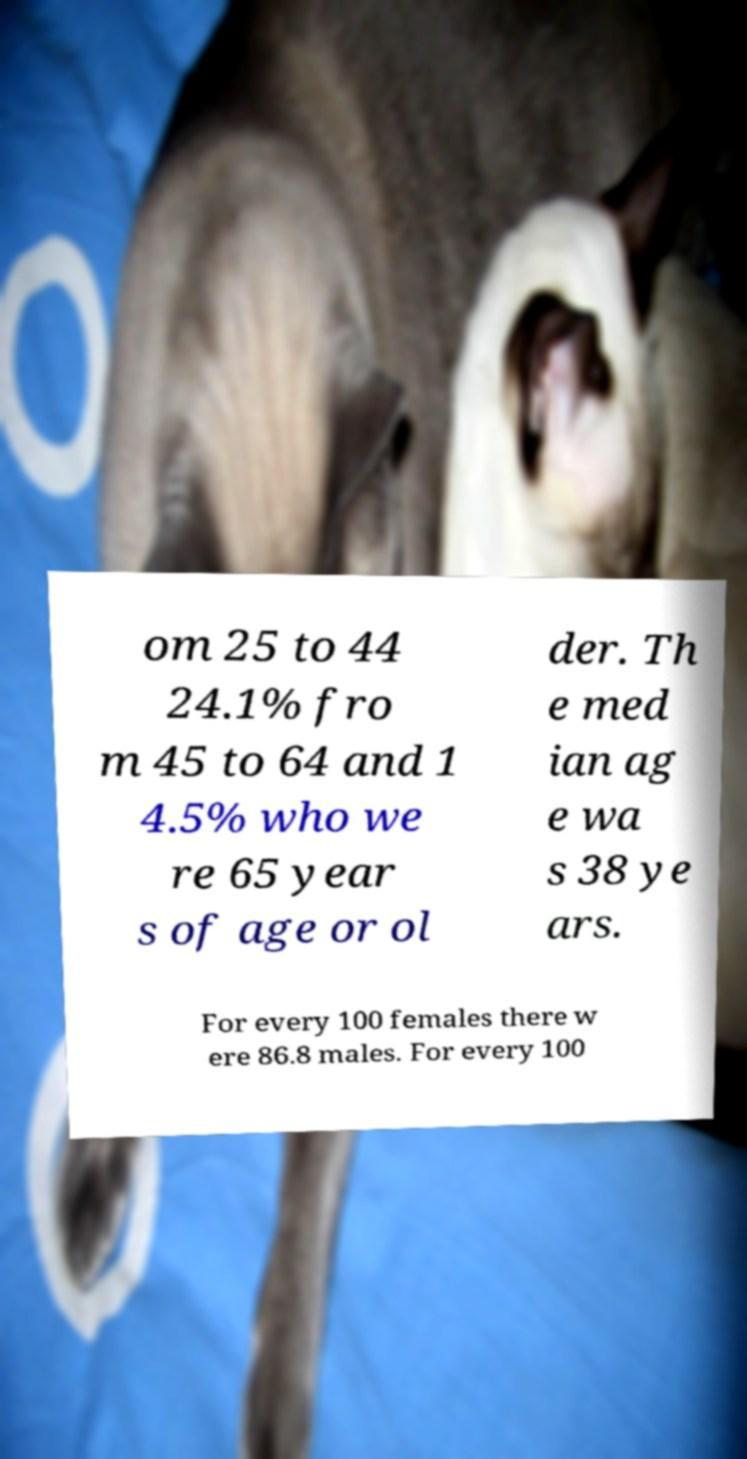What messages or text are displayed in this image? I need them in a readable, typed format. om 25 to 44 24.1% fro m 45 to 64 and 1 4.5% who we re 65 year s of age or ol der. Th e med ian ag e wa s 38 ye ars. For every 100 females there w ere 86.8 males. For every 100 